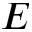Convert formula to latex. <formula><loc_0><loc_0><loc_500><loc_500>E</formula> 